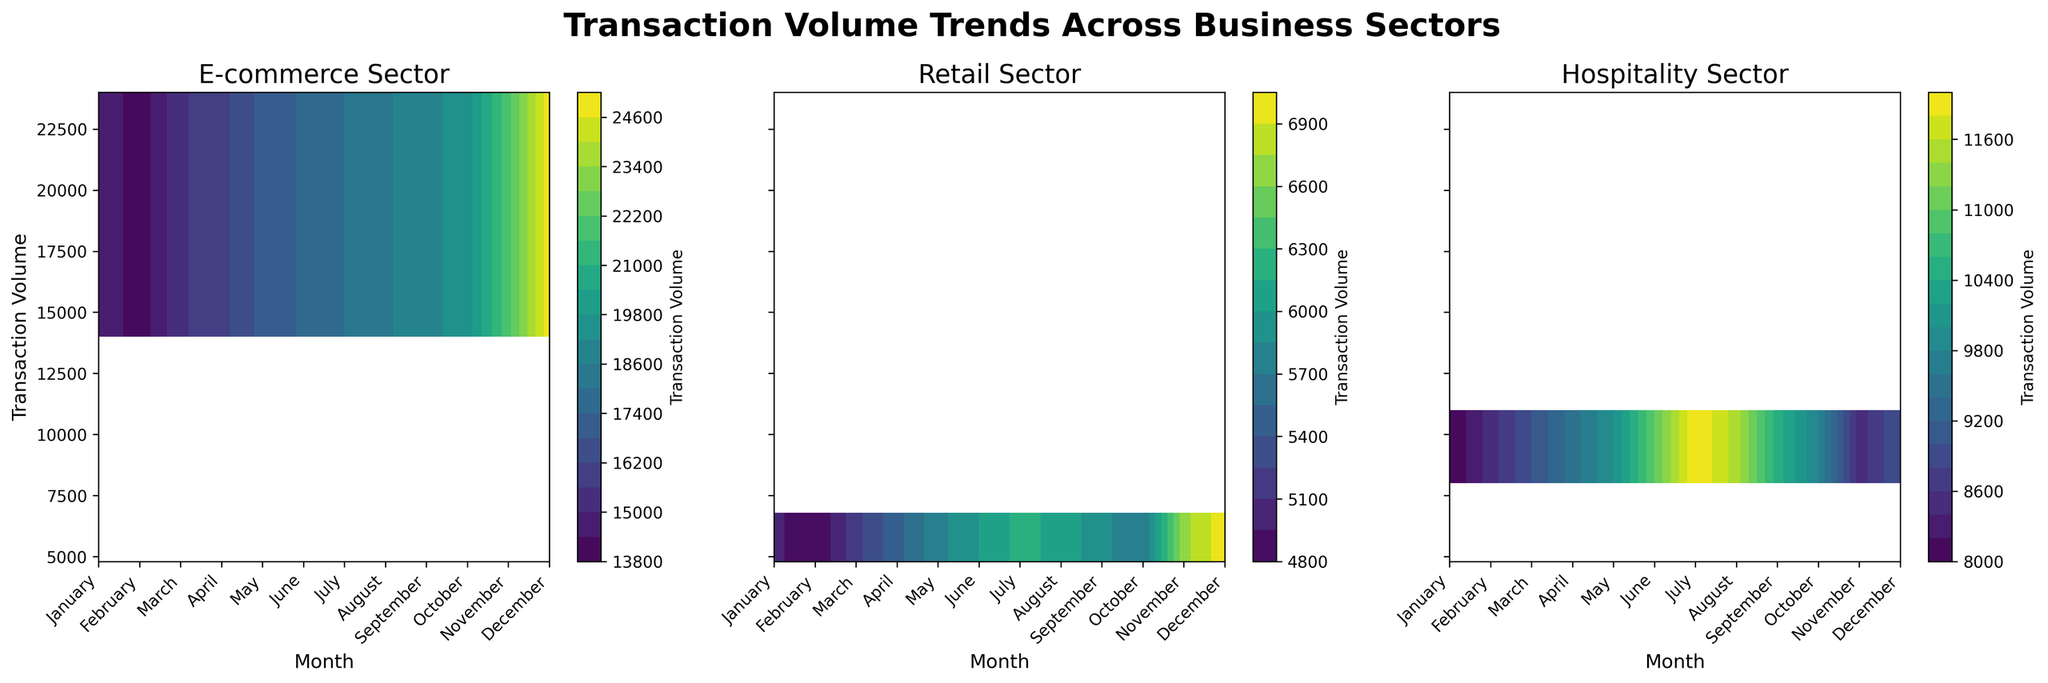What are the titles of the subplots? The titles are located at the top of each subplot. They are 'E-commerce Sector', 'Retail Sector', and 'Hospitality Sector'.
Answer: 'E-commerce Sector', 'Retail Sector', 'Hospitality Sector' Which month shows the highest transaction volume in the E-commerce sector? Observe the E-commerce sector subplot and identify the month with the highest contour level or color intensity. December shows the highest transaction volume.
Answer: December What is the color range used to represent transaction volume? Look at the color bar on any subplot; it uses a gradient from a lighter shade to a darker shade of the viridis color map to represent the range of transaction volumes.
Answer: Gradient from lighter to darker shades of viridis How does the transaction volume in the Retail sector in June compare to the Hospitality sector in July? Look at both the Retail sector subplot in June and the Hospitality sector subplot in July. The color intensity and contour levels in June for Retail are lower compared to July for Hospitality, indicating a higher transaction volume in the Hospitality sector in July.
Answer: Hospitality sector in July is higher Which business sector shows the least variation in transaction volume throughout the year? By comparing the color gradients and contour spacing across the subplots, we see that the Retail sector has the least change in color intensity over the months, indicating the least variation in transaction volume.
Answer: Retail sector In which months do the E-commerce and Hospitality sectors have similar transaction volumes? Compare the contours and colors of the E-commerce and Hospitality subplots. Both sectors have similar contours and colors in April and May, indicating similar transaction volumes.
Answer: April and May What is the trend of the E-commerce transaction volume from January to July? Looking at the E-commerce sector subplot, identify the progression of contours and colors from January to July. The transaction volume shows an increasing trend from January to July.
Answer: Increasing Which month has the lowest transaction volume in the Retail sector? Look for the month with the lightest contour color in the Retail sector subplot. February shows the lowest transaction volume.
Answer: February What happens to the Hospitality sector's transaction volume during the end of the year? Observe the Hospitality sector's subplot for October, November, and December. The colors darken significantly in December compared to the earlier months, indicating an increase in transaction volume.
Answer: Increases 